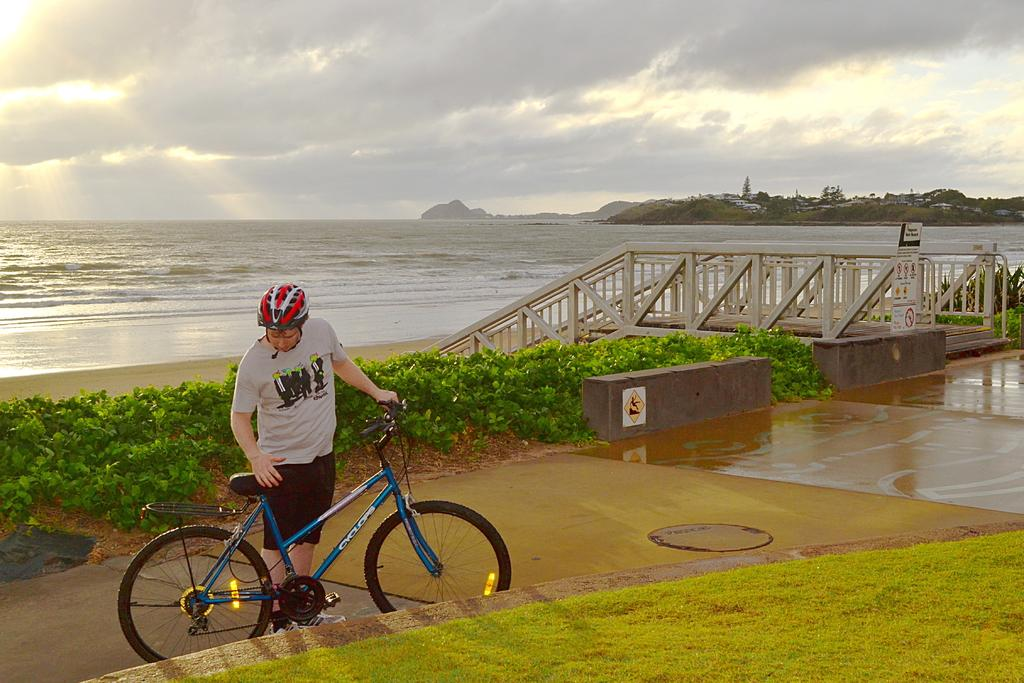What type of vegetation can be seen in the image? There is grass and plants visible in the image. What architectural feature is present in the image? There are stairs in the image. What natural element is visible in the image? There is water visible in the image. What type of structures can be seen in the image? There are buildings in the image. What is the person in the image doing? The person is holding a bicycle in the image. What is visible in the sky in the image? The sky is visible in the image, and there are clouds present. What type of letter is the kitten holding in the image? There is no kitten or letter present in the image. What type of school can be seen in the image? There is no school visible in the image. 